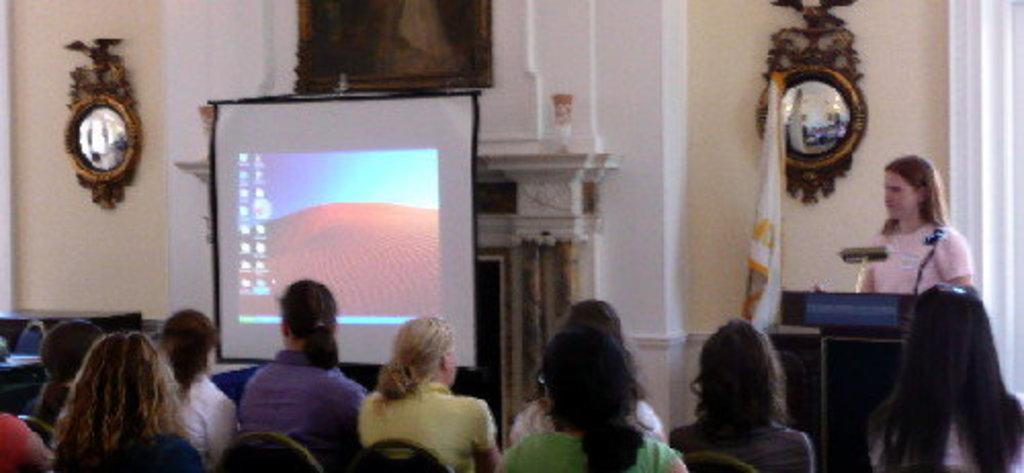Describe this image in one or two sentences. In this image there is a picture, mirrors, screen, flag, podium, people, chairs, wall and objects. Among them one person is standing and in-front of that person there is a podium. A picture and mirrors are on the wall.   